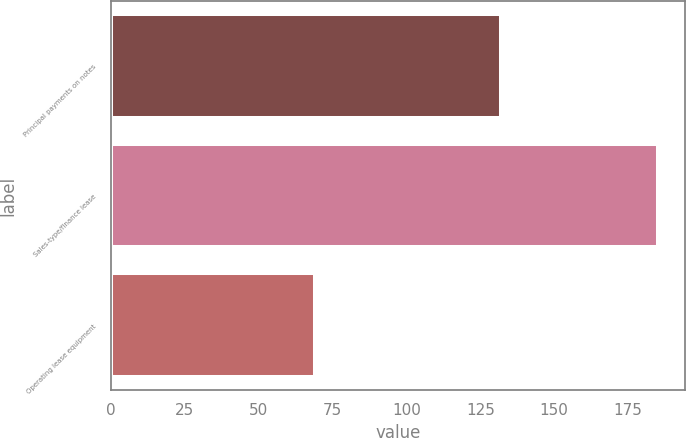Convert chart. <chart><loc_0><loc_0><loc_500><loc_500><bar_chart><fcel>Principal payments on notes<fcel>Sales-type/finance lease<fcel>Operating lease equipment<nl><fcel>132<fcel>185<fcel>69<nl></chart> 